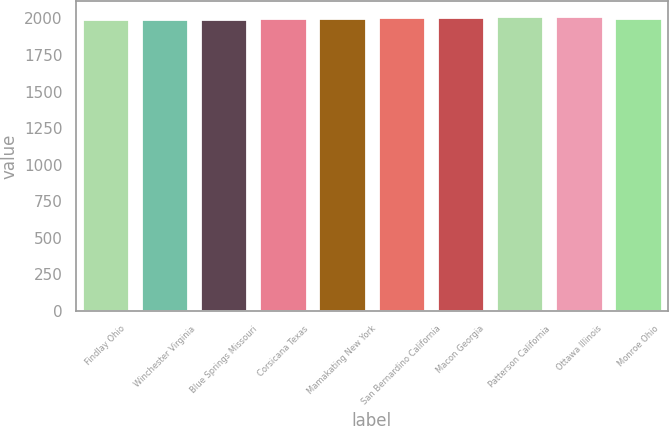Convert chart to OTSL. <chart><loc_0><loc_0><loc_500><loc_500><bar_chart><fcel>Findlay Ohio<fcel>Winchester Virginia<fcel>Blue Springs Missouri<fcel>Corsicana Texas<fcel>Mamakating New York<fcel>San Bernardino California<fcel>Macon Georgia<fcel>Patterson California<fcel>Ottawa Illinois<fcel>Monroe Ohio<nl><fcel>1994<fcel>1997<fcel>1999.3<fcel>2001.6<fcel>2006.2<fcel>2008.5<fcel>2010.8<fcel>2013.1<fcel>2015.4<fcel>2003.9<nl></chart> 